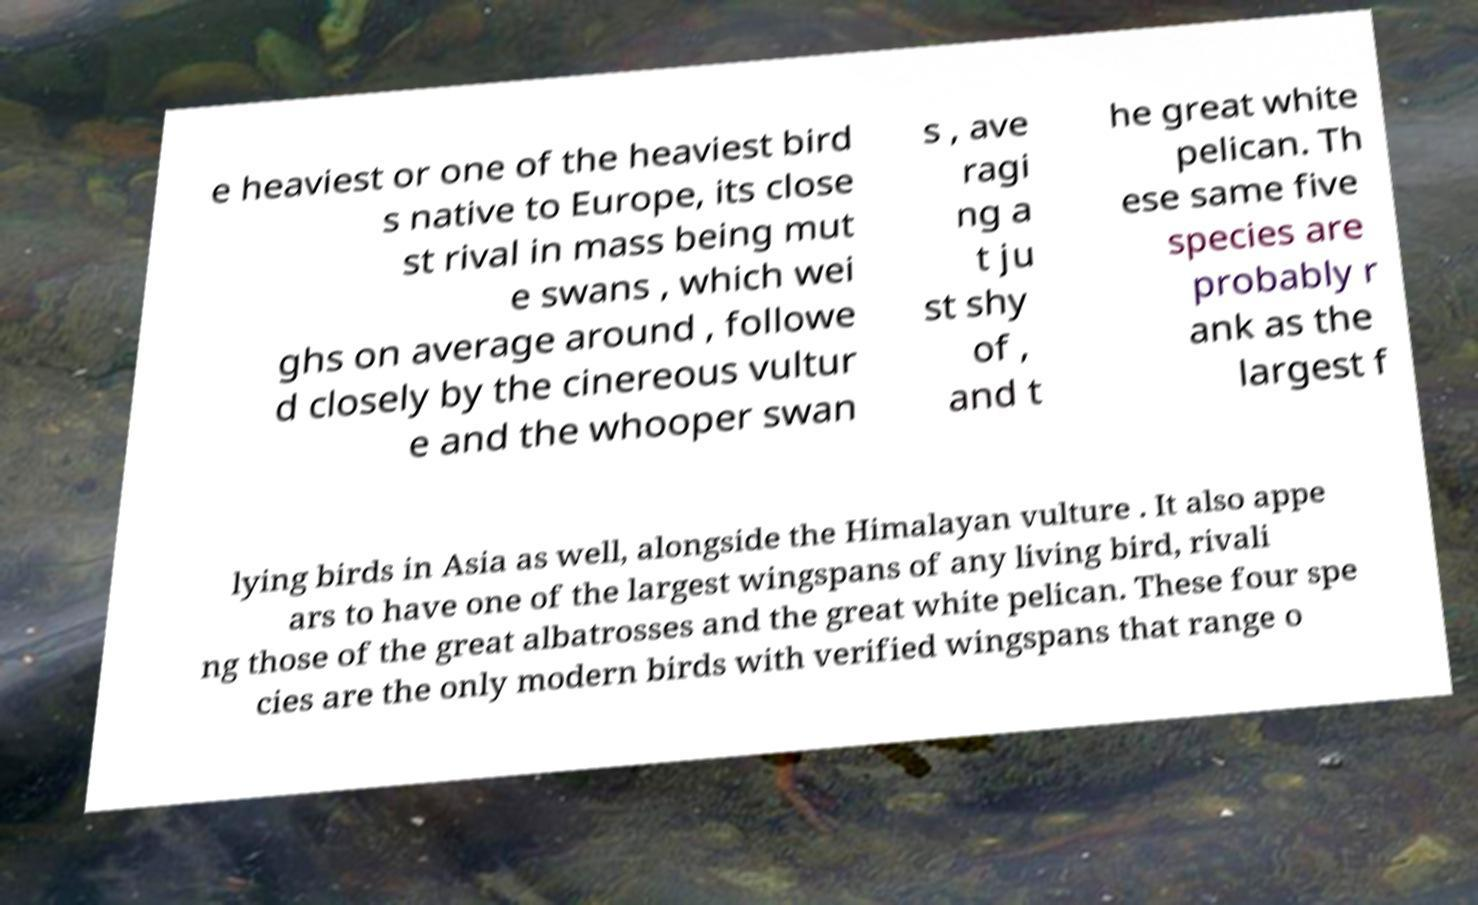There's text embedded in this image that I need extracted. Can you transcribe it verbatim? e heaviest or one of the heaviest bird s native to Europe, its close st rival in mass being mut e swans , which wei ghs on average around , followe d closely by the cinereous vultur e and the whooper swan s , ave ragi ng a t ju st shy of , and t he great white pelican. Th ese same five species are probably r ank as the largest f lying birds in Asia as well, alongside the Himalayan vulture . It also appe ars to have one of the largest wingspans of any living bird, rivali ng those of the great albatrosses and the great white pelican. These four spe cies are the only modern birds with verified wingspans that range o 